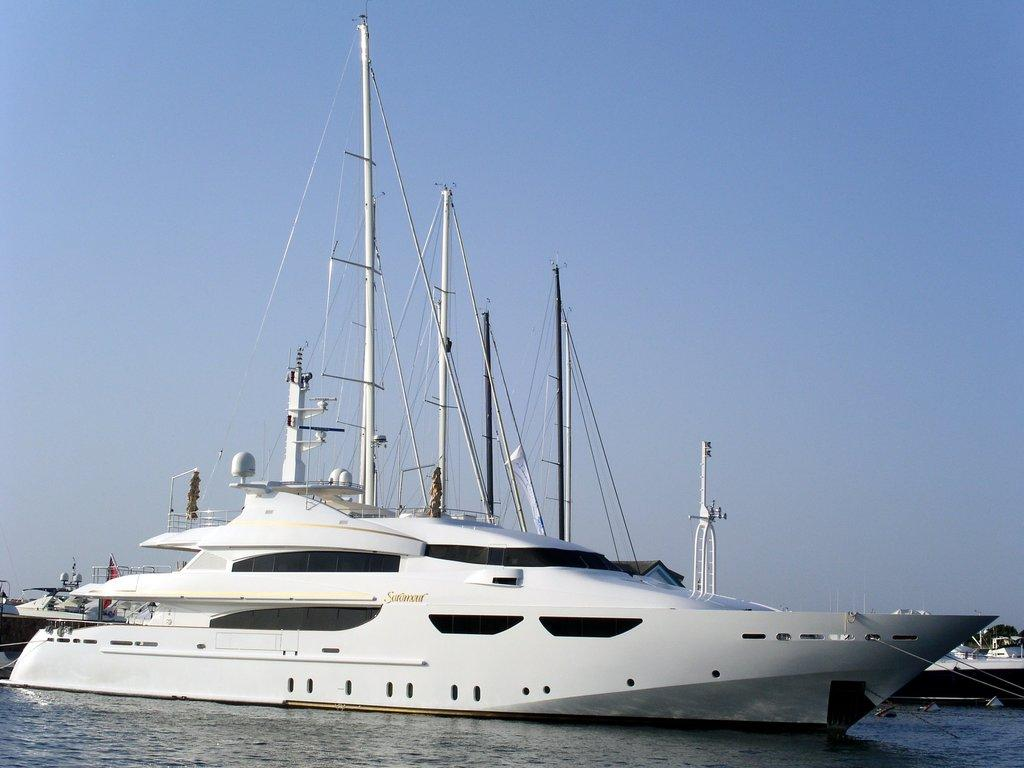What is at the bottom of the image? There is water at the bottom of the image. What can be seen in the middle of the image? There is a ship in the middle of the image. What type of vegetation is visible in the background of the image? There is a tree visible in the background of the image. What is visible at the top of the image? The sky is visible at the top of the image. What type of fish can be seen swimming in the water in the image? There are no fish visible in the image; it only shows water at the bottom. What type of society is depicted in the image? The image does not depict any society; it features a ship on water with a tree and sky in the background. 